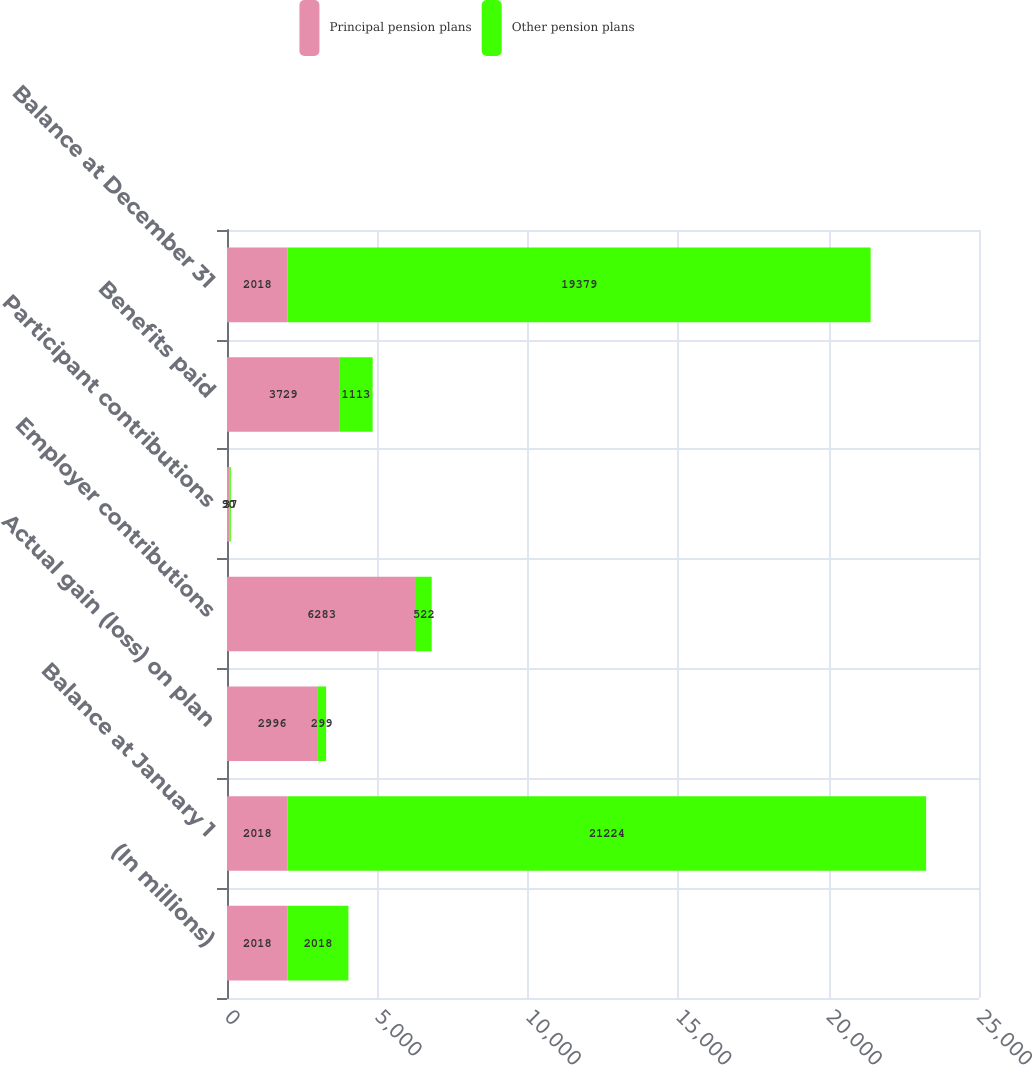Convert chart. <chart><loc_0><loc_0><loc_500><loc_500><stacked_bar_chart><ecel><fcel>(In millions)<fcel>Balance at January 1<fcel>Actual gain (loss) on plan<fcel>Employer contributions<fcel>Participant contributions<fcel>Benefits paid<fcel>Balance at December 31<nl><fcel>Principal pension plans<fcel>2018<fcel>2018<fcel>2996<fcel>6283<fcel>90<fcel>3729<fcel>2018<nl><fcel>Other pension plans<fcel>2018<fcel>21224<fcel>299<fcel>522<fcel>37<fcel>1113<fcel>19379<nl></chart> 